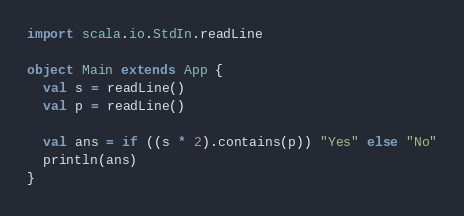<code> <loc_0><loc_0><loc_500><loc_500><_Scala_>import scala.io.StdIn.readLine

object Main extends App {
  val s = readLine()
  val p = readLine()

  val ans = if ((s * 2).contains(p)) "Yes" else "No"
  println(ans)
}

</code> 